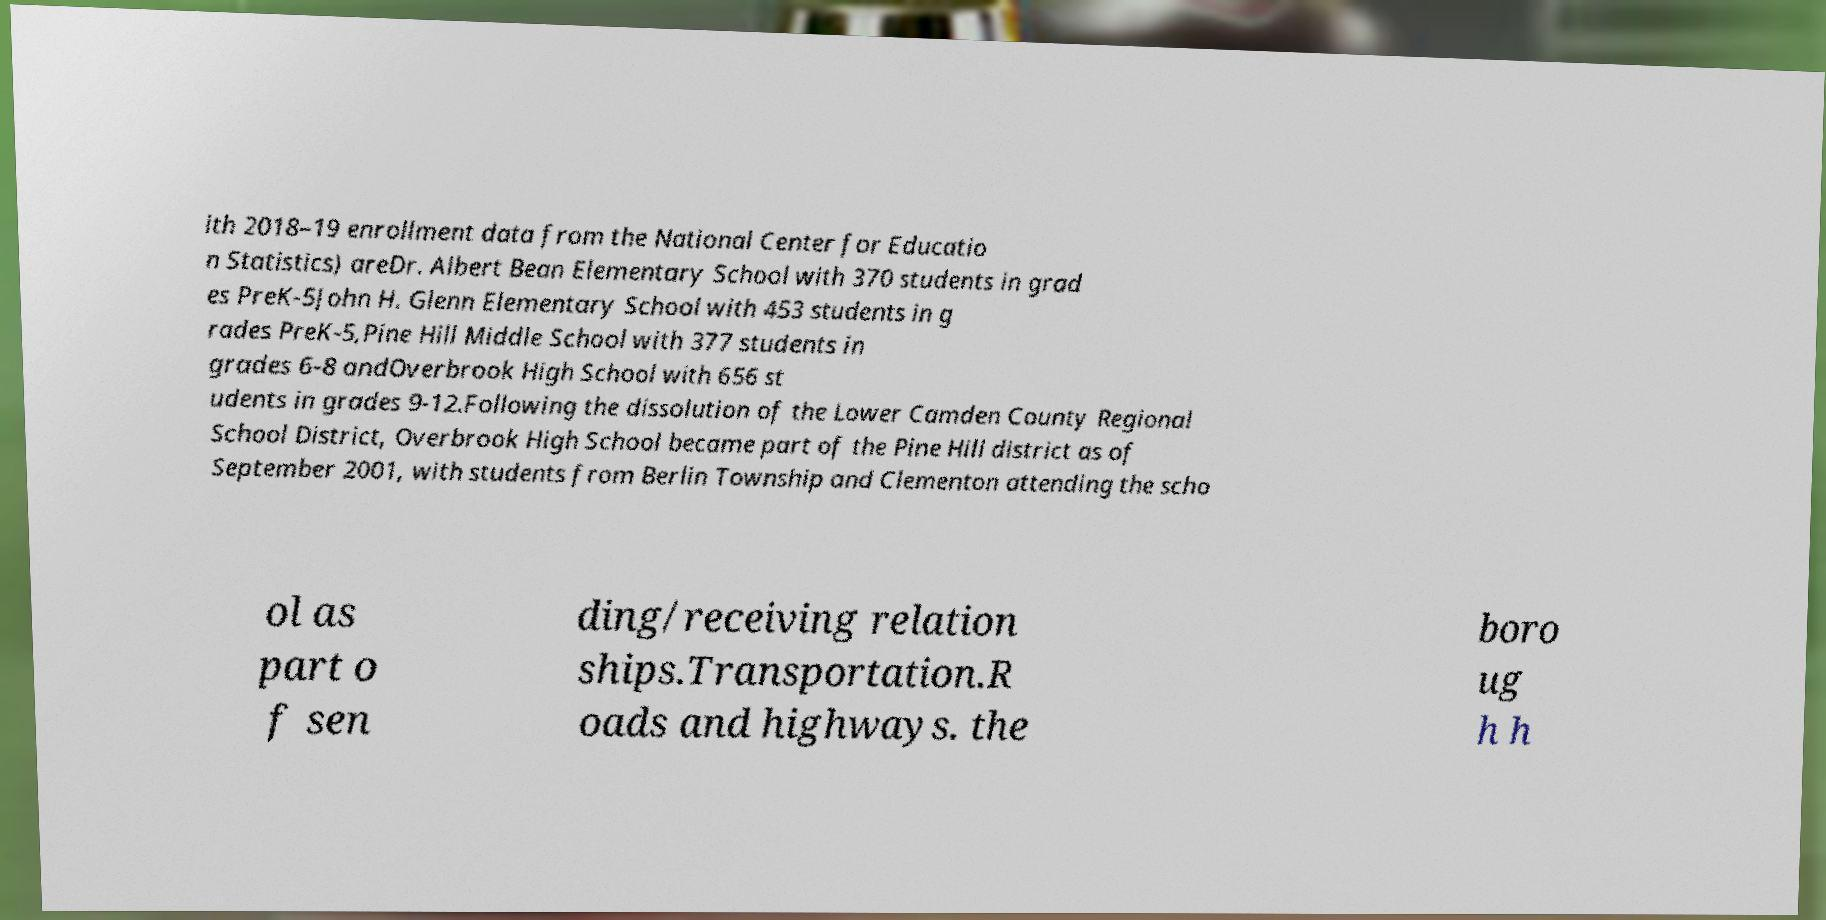Could you assist in decoding the text presented in this image and type it out clearly? ith 2018–19 enrollment data from the National Center for Educatio n Statistics) areDr. Albert Bean Elementary School with 370 students in grad es PreK-5John H. Glenn Elementary School with 453 students in g rades PreK-5,Pine Hill Middle School with 377 students in grades 6-8 andOverbrook High School with 656 st udents in grades 9-12.Following the dissolution of the Lower Camden County Regional School District, Overbrook High School became part of the Pine Hill district as of September 2001, with students from Berlin Township and Clementon attending the scho ol as part o f sen ding/receiving relation ships.Transportation.R oads and highways. the boro ug h h 